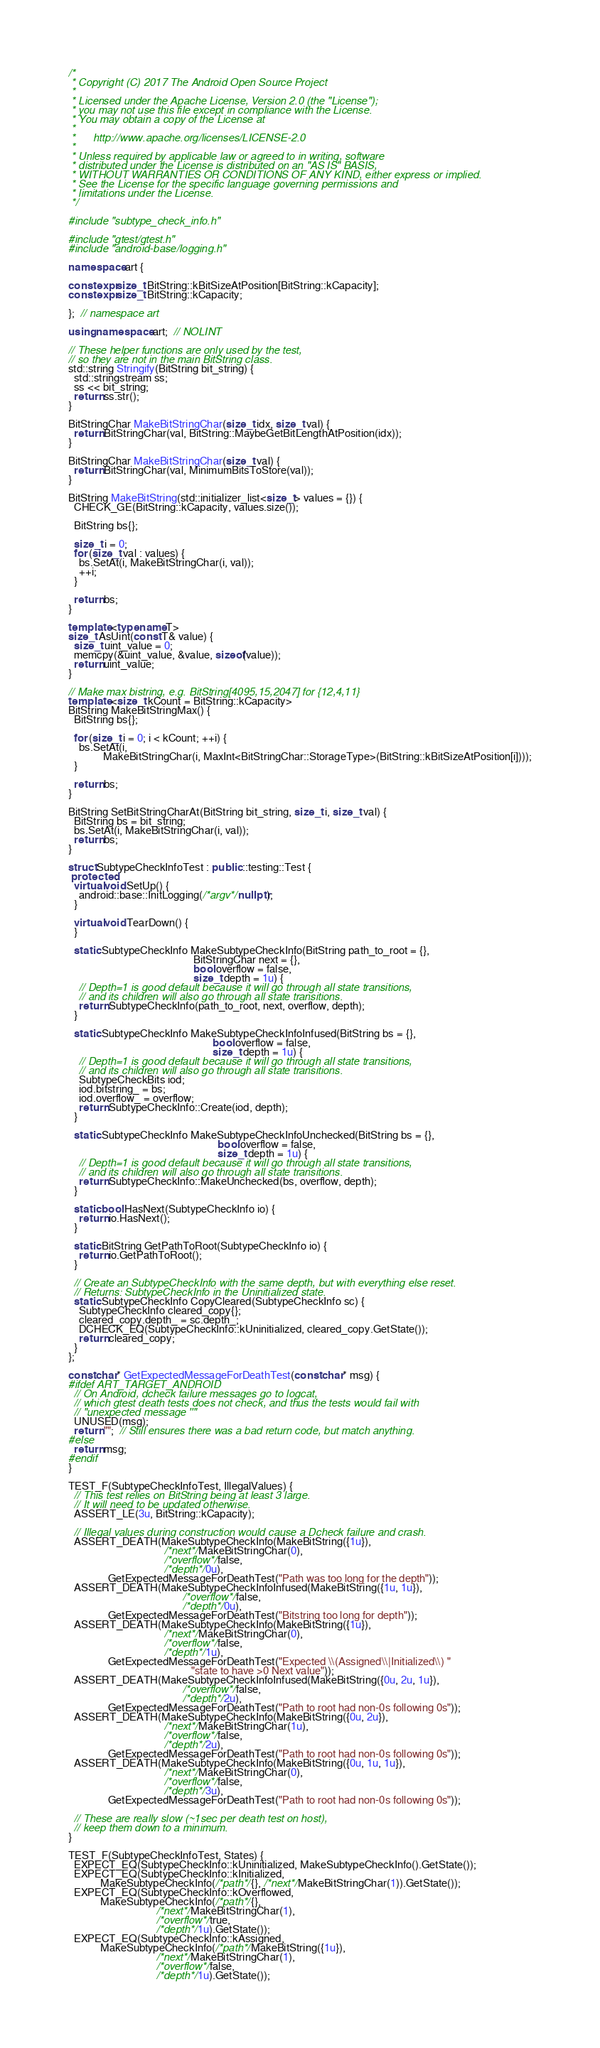<code> <loc_0><loc_0><loc_500><loc_500><_C++_>/*
 * Copyright (C) 2017 The Android Open Source Project
 *
 * Licensed under the Apache License, Version 2.0 (the "License");
 * you may not use this file except in compliance with the License.
 * You may obtain a copy of the License at
 *
 *      http://www.apache.org/licenses/LICENSE-2.0
 *
 * Unless required by applicable law or agreed to in writing, software
 * distributed under the License is distributed on an "AS IS" BASIS,
 * WITHOUT WARRANTIES OR CONDITIONS OF ANY KIND, either express or implied.
 * See the License for the specific language governing permissions and
 * limitations under the License.
 */

#include "subtype_check_info.h"

#include "gtest/gtest.h"
#include "android-base/logging.h"

namespace art {

constexpr size_t BitString::kBitSizeAtPosition[BitString::kCapacity];
constexpr size_t BitString::kCapacity;

};  // namespace art

using namespace art;  // NOLINT

// These helper functions are only used by the test,
// so they are not in the main BitString class.
std::string Stringify(BitString bit_string) {
  std::stringstream ss;
  ss << bit_string;
  return ss.str();
}

BitStringChar MakeBitStringChar(size_t idx, size_t val) {
  return BitStringChar(val, BitString::MaybeGetBitLengthAtPosition(idx));
}

BitStringChar MakeBitStringChar(size_t val) {
  return BitStringChar(val, MinimumBitsToStore(val));
}

BitString MakeBitString(std::initializer_list<size_t> values = {}) {
  CHECK_GE(BitString::kCapacity, values.size());

  BitString bs{};

  size_t i = 0;
  for (size_t val : values) {
    bs.SetAt(i, MakeBitStringChar(i, val));
    ++i;
  }

  return bs;
}

template <typename T>
size_t AsUint(const T& value) {
  size_t uint_value = 0;
  memcpy(&uint_value, &value, sizeof(value));
  return uint_value;
}

// Make max bistring, e.g. BitString[4095,15,2047] for {12,4,11}
template <size_t kCount = BitString::kCapacity>
BitString MakeBitStringMax() {
  BitString bs{};

  for (size_t i = 0; i < kCount; ++i) {
    bs.SetAt(i,
             MakeBitStringChar(i, MaxInt<BitStringChar::StorageType>(BitString::kBitSizeAtPosition[i])));
  }

  return bs;
}

BitString SetBitStringCharAt(BitString bit_string, size_t i, size_t val) {
  BitString bs = bit_string;
  bs.SetAt(i, MakeBitStringChar(i, val));
  return bs;
}

struct SubtypeCheckInfoTest : public ::testing::Test {
 protected:
  virtual void SetUp() {
    android::base::InitLogging(/*argv*/nullptr);
  }

  virtual void TearDown() {
  }

  static SubtypeCheckInfo MakeSubtypeCheckInfo(BitString path_to_root = {},
                                               BitStringChar next = {},
                                               bool overflow = false,
                                               size_t depth = 1u) {
    // Depth=1 is good default because it will go through all state transitions,
    // and its children will also go through all state transitions.
    return SubtypeCheckInfo(path_to_root, next, overflow, depth);
  }

  static SubtypeCheckInfo MakeSubtypeCheckInfoInfused(BitString bs = {},
                                                      bool overflow = false,
                                                      size_t depth = 1u) {
    // Depth=1 is good default because it will go through all state transitions,
    // and its children will also go through all state transitions.
    SubtypeCheckBits iod;
    iod.bitstring_ = bs;
    iod.overflow_ = overflow;
    return SubtypeCheckInfo::Create(iod, depth);
  }

  static SubtypeCheckInfo MakeSubtypeCheckInfoUnchecked(BitString bs = {},
                                                        bool overflow = false,
                                                        size_t depth = 1u) {
    // Depth=1 is good default because it will go through all state transitions,
    // and its children will also go through all state transitions.
    return SubtypeCheckInfo::MakeUnchecked(bs, overflow, depth);
  }

  static bool HasNext(SubtypeCheckInfo io) {
    return io.HasNext();
  }

  static BitString GetPathToRoot(SubtypeCheckInfo io) {
    return io.GetPathToRoot();
  }

  // Create an SubtypeCheckInfo with the same depth, but with everything else reset.
  // Returns: SubtypeCheckInfo in the Uninitialized state.
  static SubtypeCheckInfo CopyCleared(SubtypeCheckInfo sc) {
    SubtypeCheckInfo cleared_copy{};
    cleared_copy.depth_ = sc.depth_;
    DCHECK_EQ(SubtypeCheckInfo::kUninitialized, cleared_copy.GetState());
    return cleared_copy;
  }
};

const char* GetExpectedMessageForDeathTest(const char* msg) {
#ifdef ART_TARGET_ANDROID
  // On Android, dcheck failure messages go to logcat,
  // which gtest death tests does not check, and thus the tests would fail with
  // "unexpected message ''"
  UNUSED(msg);
  return "";  // Still ensures there was a bad return code, but match anything.
#else
  return msg;
#endif
}

TEST_F(SubtypeCheckInfoTest, IllegalValues) {
  // This test relies on BitString being at least 3 large.
  // It will need to be updated otherwise.
  ASSERT_LE(3u, BitString::kCapacity);

  // Illegal values during construction would cause a Dcheck failure and crash.
  ASSERT_DEATH(MakeSubtypeCheckInfo(MakeBitString({1u}),
                                    /*next*/MakeBitStringChar(0),
                                    /*overflow*/false,
                                    /*depth*/0u),
               GetExpectedMessageForDeathTest("Path was too long for the depth"));
  ASSERT_DEATH(MakeSubtypeCheckInfoInfused(MakeBitString({1u, 1u}),
                                           /*overflow*/false,
                                           /*depth*/0u),
               GetExpectedMessageForDeathTest("Bitstring too long for depth"));
  ASSERT_DEATH(MakeSubtypeCheckInfo(MakeBitString({1u}),
                                    /*next*/MakeBitStringChar(0),
                                    /*overflow*/false,
                                    /*depth*/1u),
               GetExpectedMessageForDeathTest("Expected \\(Assigned\\|Initialized\\) "
                                              "state to have >0 Next value"));
  ASSERT_DEATH(MakeSubtypeCheckInfoInfused(MakeBitString({0u, 2u, 1u}),
                                           /*overflow*/false,
                                           /*depth*/2u),
               GetExpectedMessageForDeathTest("Path to root had non-0s following 0s"));
  ASSERT_DEATH(MakeSubtypeCheckInfo(MakeBitString({0u, 2u}),
                                    /*next*/MakeBitStringChar(1u),
                                    /*overflow*/false,
                                    /*depth*/2u),
               GetExpectedMessageForDeathTest("Path to root had non-0s following 0s"));
  ASSERT_DEATH(MakeSubtypeCheckInfo(MakeBitString({0u, 1u, 1u}),
                                    /*next*/MakeBitStringChar(0),
                                    /*overflow*/false,
                                    /*depth*/3u),
               GetExpectedMessageForDeathTest("Path to root had non-0s following 0s"));

  // These are really slow (~1sec per death test on host),
  // keep them down to a minimum.
}

TEST_F(SubtypeCheckInfoTest, States) {
  EXPECT_EQ(SubtypeCheckInfo::kUninitialized, MakeSubtypeCheckInfo().GetState());
  EXPECT_EQ(SubtypeCheckInfo::kInitialized,
            MakeSubtypeCheckInfo(/*path*/{}, /*next*/MakeBitStringChar(1)).GetState());
  EXPECT_EQ(SubtypeCheckInfo::kOverflowed,
            MakeSubtypeCheckInfo(/*path*/{},
                                 /*next*/MakeBitStringChar(1),
                                 /*overflow*/true,
                                 /*depth*/1u).GetState());
  EXPECT_EQ(SubtypeCheckInfo::kAssigned,
            MakeSubtypeCheckInfo(/*path*/MakeBitString({1u}),
                                 /*next*/MakeBitStringChar(1),
                                 /*overflow*/false,
                                 /*depth*/1u).GetState());
</code> 